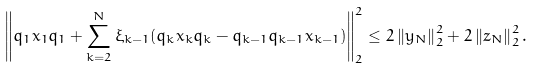Convert formula to latex. <formula><loc_0><loc_0><loc_500><loc_500>\left \| q _ { 1 } x _ { 1 } q _ { 1 } + \sum ^ { N } _ { k = 2 } \xi _ { k - 1 } ( q _ { k } x _ { k } q _ { k } - q _ { k - 1 } q _ { k - 1 } x _ { k - 1 } ) \right \| ^ { 2 } _ { 2 } \leq 2 \left \| y _ { N } \right \| _ { 2 } ^ { 2 } + 2 \left \| z _ { N } \right \| ^ { 2 } _ { 2 } .</formula> 